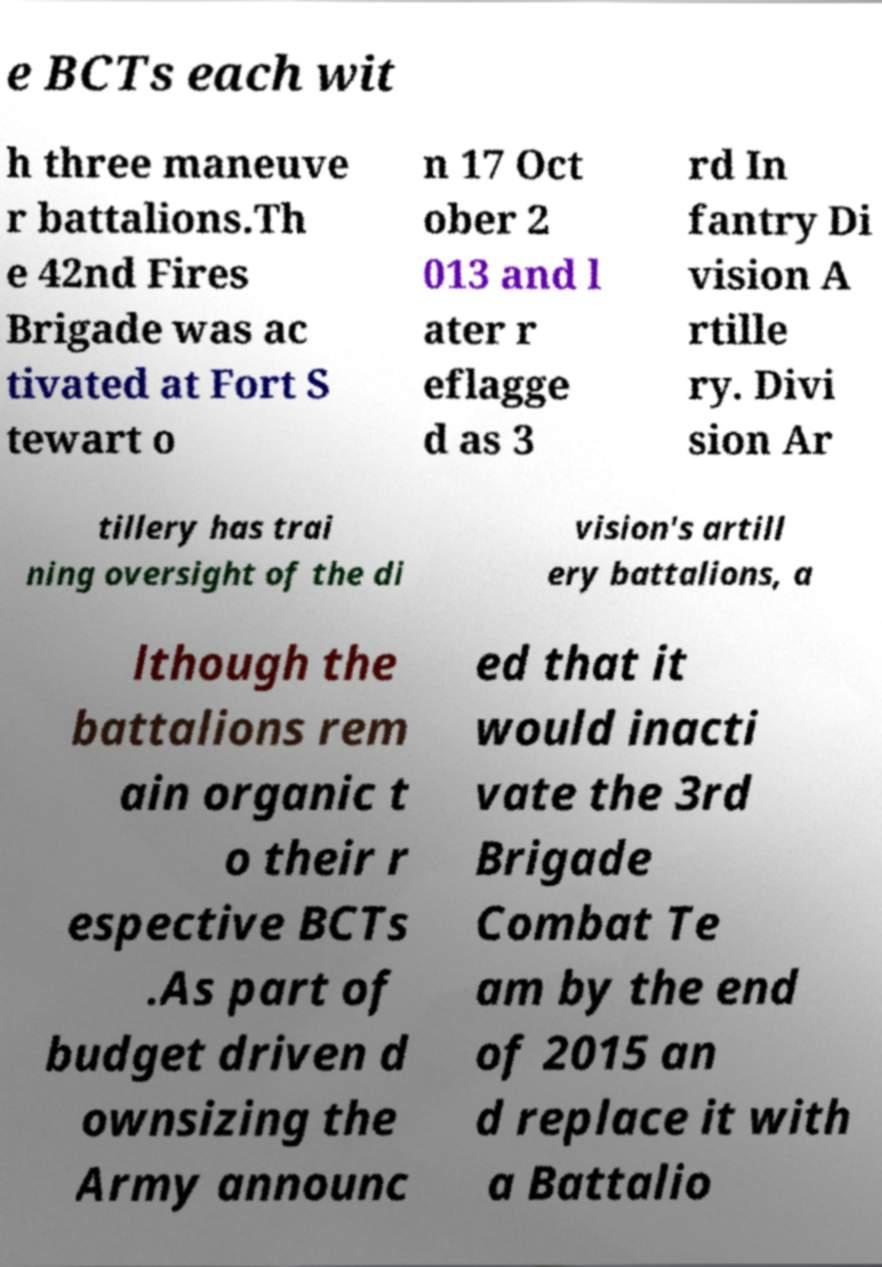Could you assist in decoding the text presented in this image and type it out clearly? e BCTs each wit h three maneuve r battalions.Th e 42nd Fires Brigade was ac tivated at Fort S tewart o n 17 Oct ober 2 013 and l ater r eflagge d as 3 rd In fantry Di vision A rtille ry. Divi sion Ar tillery has trai ning oversight of the di vision's artill ery battalions, a lthough the battalions rem ain organic t o their r espective BCTs .As part of budget driven d ownsizing the Army announc ed that it would inacti vate the 3rd Brigade Combat Te am by the end of 2015 an d replace it with a Battalio 